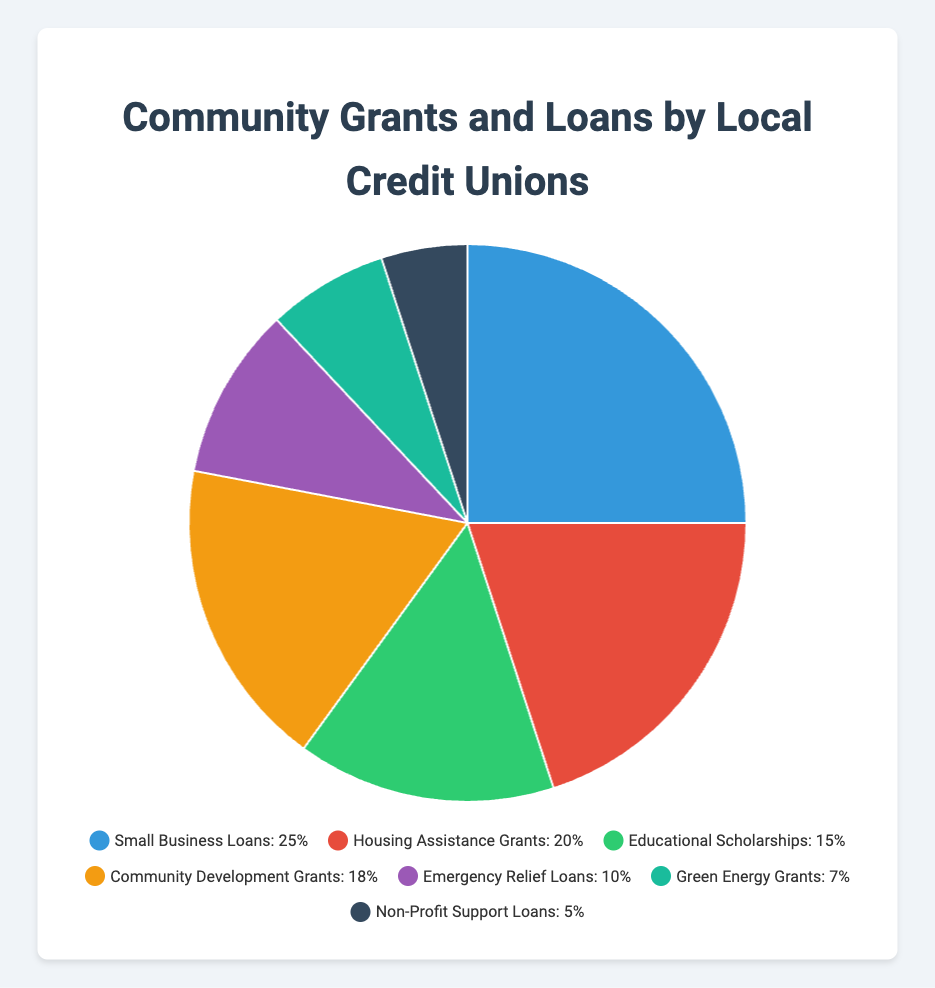what is the percentage difference between Small Business Loans and Housing Assistance Grants? To find the percentage difference, subtract the Housing Assistance Grants percentage from the Small Business Loans percentage: 25% - 20% = 5%.
Answer: 5% Which category receives the smallest percentage of grants and loans? By looking at the pie chart, the smallest segment represents Non-Profit Support Loans which have a percentage of 5%.
Answer: Non-Profit Support Loans What is the total percentage of grants and loans dedicated to educational and community development purposes? Add the percentages of Educational Scholarships and Community Development Grants: 15% + 18% = 33%.
Answer: 33% How many categories have a higher percentage than Green Energy Grants? From the pie chart, the categories with higher percentages than Green Energy Grants (7%) are Small Business Loans (25%), Housing Assistance Grants (20%), Educational Scholarships (15%), Community Development Grants (18%), and Emergency Relief Loans (10%). Hence, there are 5 categories.
Answer: 5 Is the percentage of Emergency Relief Loans closer to Housing Assistance Grants or Green Energy Grants? Calculate the differences: Emergency Relief Loans as compared to Housing Assistance Grants: 20% - 10% = 10%. Emergency Relief Loans as compared to Green Energy Grants: 10% - 7% = 3%. Since 3% < 10%, it is closer to Green Energy Grants.
Answer: Green Energy Grants Which categories have double-digit percentage allocations? From the pie chart, the categories with double-digit percentages are Small Business Loans (25%), Housing Assistance Grants (20%), Educational Scholarships (15%), Community Development Grants (18%), and Emergency Relief Loans (10%).
Answer: Small Business Loans, Housing Assistance Grants, Educational Scholarships, Community Development Grants, Emergency Relief Loans What color represents the Non-Profit Support Loans in the chart? By looking at the legend in the pie chart, the color representing Non-Profit Support Loans is navy blue.
Answer: navy blue 